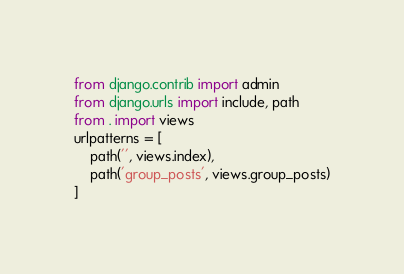<code> <loc_0><loc_0><loc_500><loc_500><_Python_>from django.contrib import admin
from django.urls import include, path
from . import views
urlpatterns = [
    path('', views.index),
    path('group_posts', views.group_posts)
]
</code> 